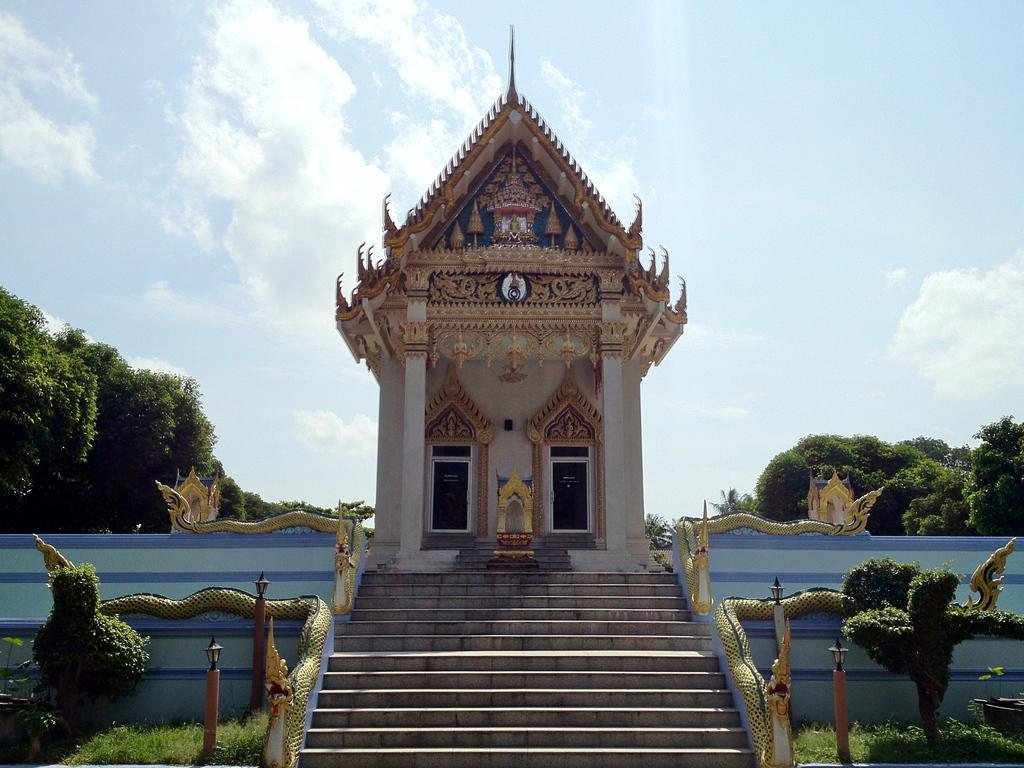Describe this image in one or two sentences. In the foreground of the of the picture there are plants, grass, staircase and a construction. In the background there are trees. Sky is sunny. 